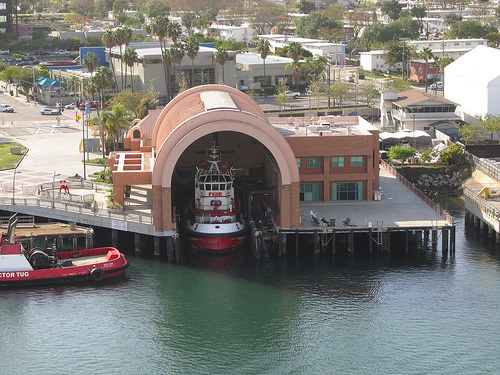<image>
Is there a boat on the stream? Yes. Looking at the image, I can see the boat is positioned on top of the stream, with the stream providing support. 